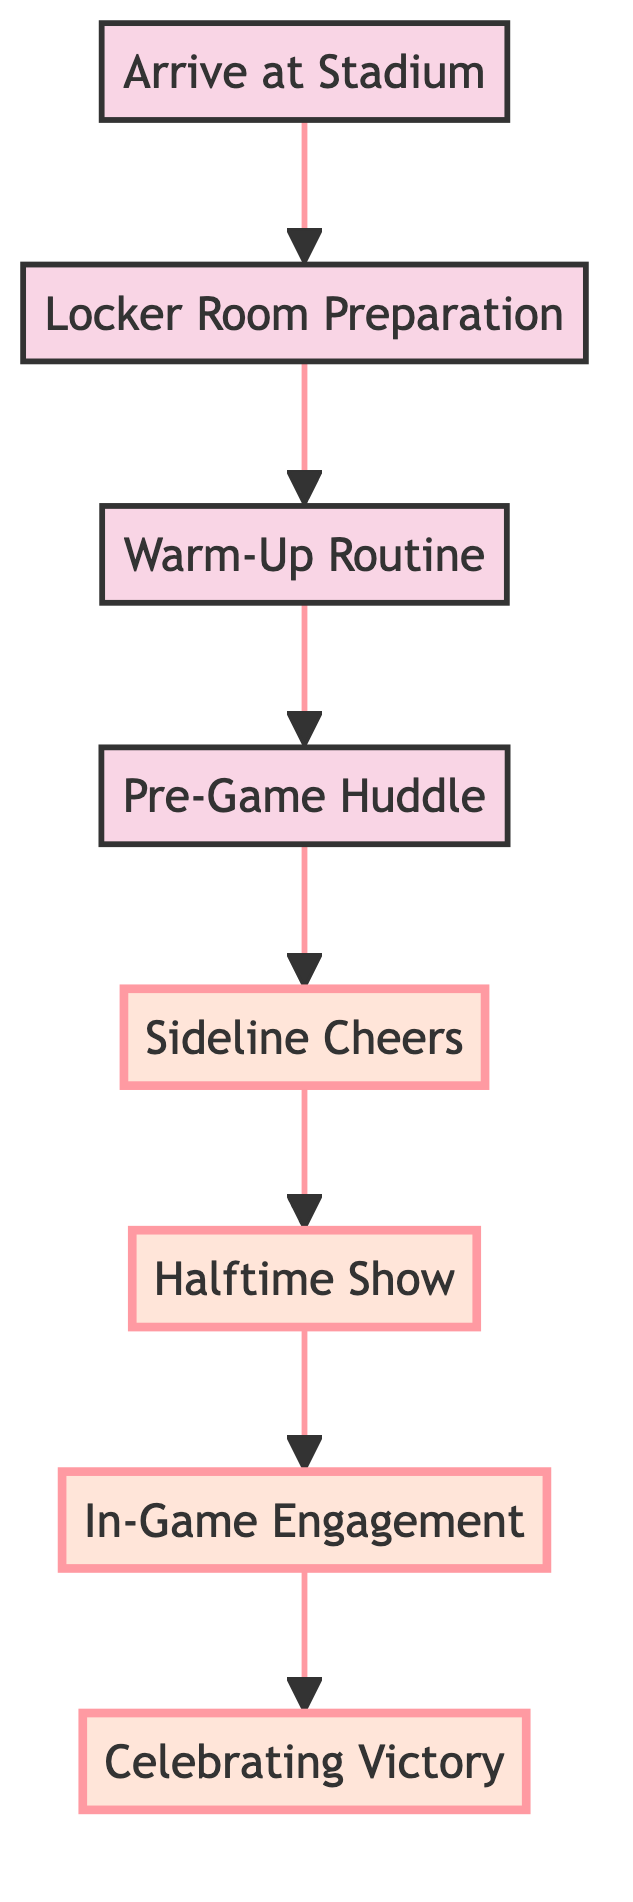What is the first step in the journey? The first step in the journey, as indicated by the bottom node of the flow chart, is "Arrive at Stadium".
Answer: Arrive at Stadium How many main stages are in the journey? To determine the number of main stages, count the nodes in the diagram. There are eight stages, from "Arrive at Stadium" to "Celebrating Victory".
Answer: Eight Which step follows "Warm-Up Routine"? The node that comes directly after "Warm-Up Routine" in the flow is "Pre-Game Huddle".
Answer: Pre-Game Huddle What is the last action in the journey? The final action in the flow chart, found at the top node, is "Celebrating Victory".
Answer: Celebrating Victory Which activities are highlighted in the diagram? The highlighted activities in the diagram are "Sideline Cheers", "Halftime Show", "In-Game Engagement", and "Celebrating Victory".
Answer: Sideline Cheers, Halftime Show, In-Game Engagement, Celebrating Victory How does "Halftime Show" relate to "In-Game Engagement"? The flow chart shows that "Halftime Show" is followed by "In-Game Engagement", indicating a sequential relationship where one occurs after the other.
Answer: Halftime Show is followed by In-Game Engagement What activity occurs directly before "Celebrating Victory"? The step right before "Celebrating Victory", as seen in the flow, is "In-Game Engagement".
Answer: In-Game Engagement What is the connecting relationship between "Pre-Game Huddle" and "Sideline Cheers"? "Sideline Cheers" follows directly after "Pre-Game Huddle", indicating that cheers are performed after the motivational gathering.
Answer: Pre-Game Huddle leads to Sideline Cheers Which node has the largest font size? The largest font size in the diagram is associated with "Celebrating Victory", which has the greatest emphasis.
Answer: Celebrating Victory 